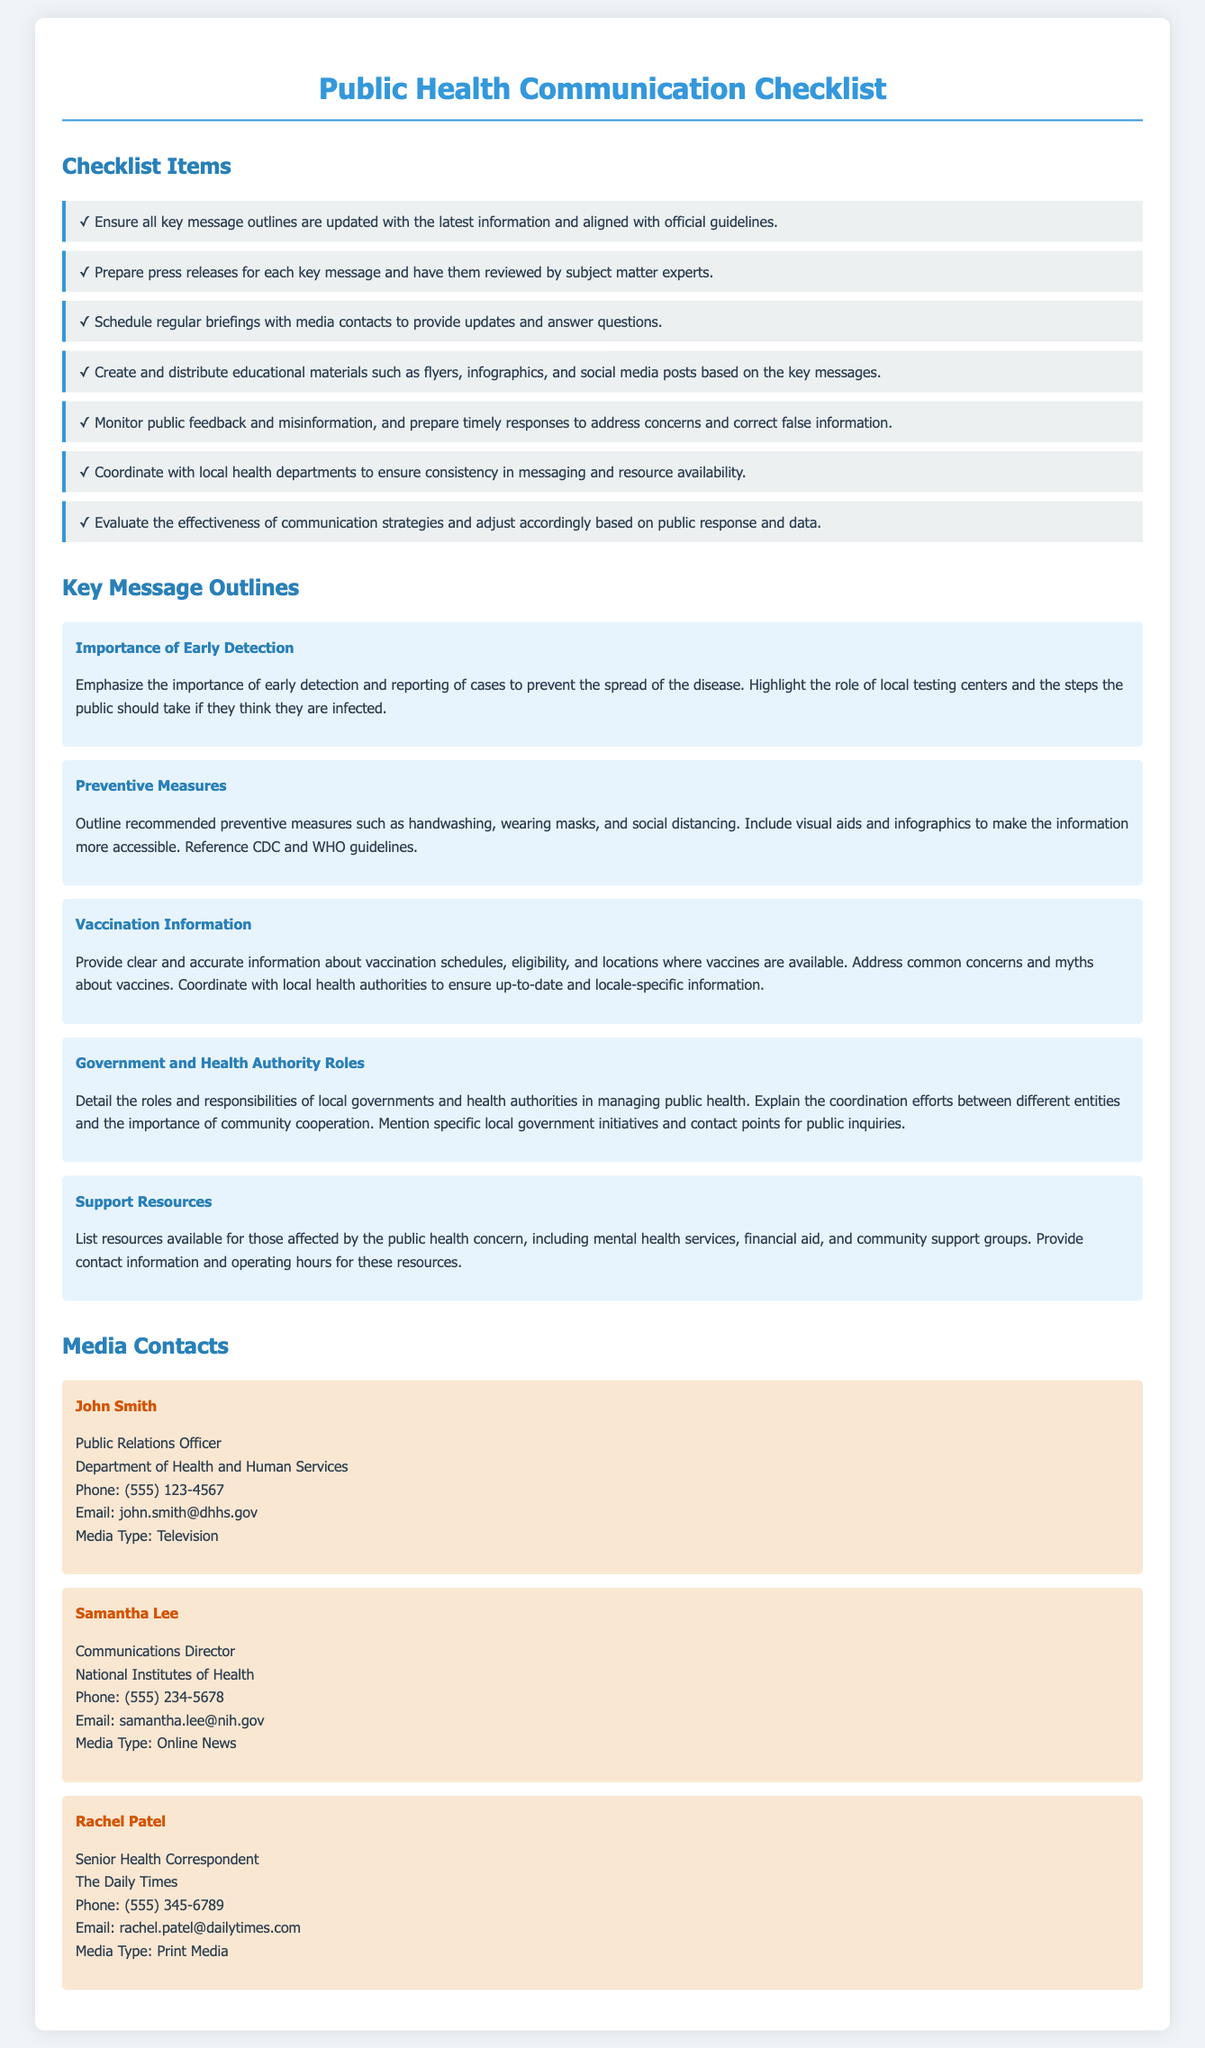What is the title of the checklist? The title of the checklist is provided in the header of the document.
Answer: Public Health Communication Checklist Who should review the press releases? The checklist specifies that press releases need to be reviewed by certain experts.
Answer: Subject matter experts What is one preventive measure outlined? The message outline includes recommended preventive measures for public health.
Answer: Handwashing How many media contacts are listed? The document contains a specific section that lists media contacts.
Answer: Three What is the phone number for John Smith? The contact details for John Smith are included under media contacts.
Answer: (555) 123-4567 What type of media is Rachel Patel associated with? The document specifies the media type associated with each media contact.
Answer: Print Media What does the message regarding vaccination information address? The message outline discusses specific concerns related to vaccination schedules.
Answer: Common concerns and myths Name one resource available for those affected. The checklist outlines support resources available for the affected individuals.
Answer: Mental health services 